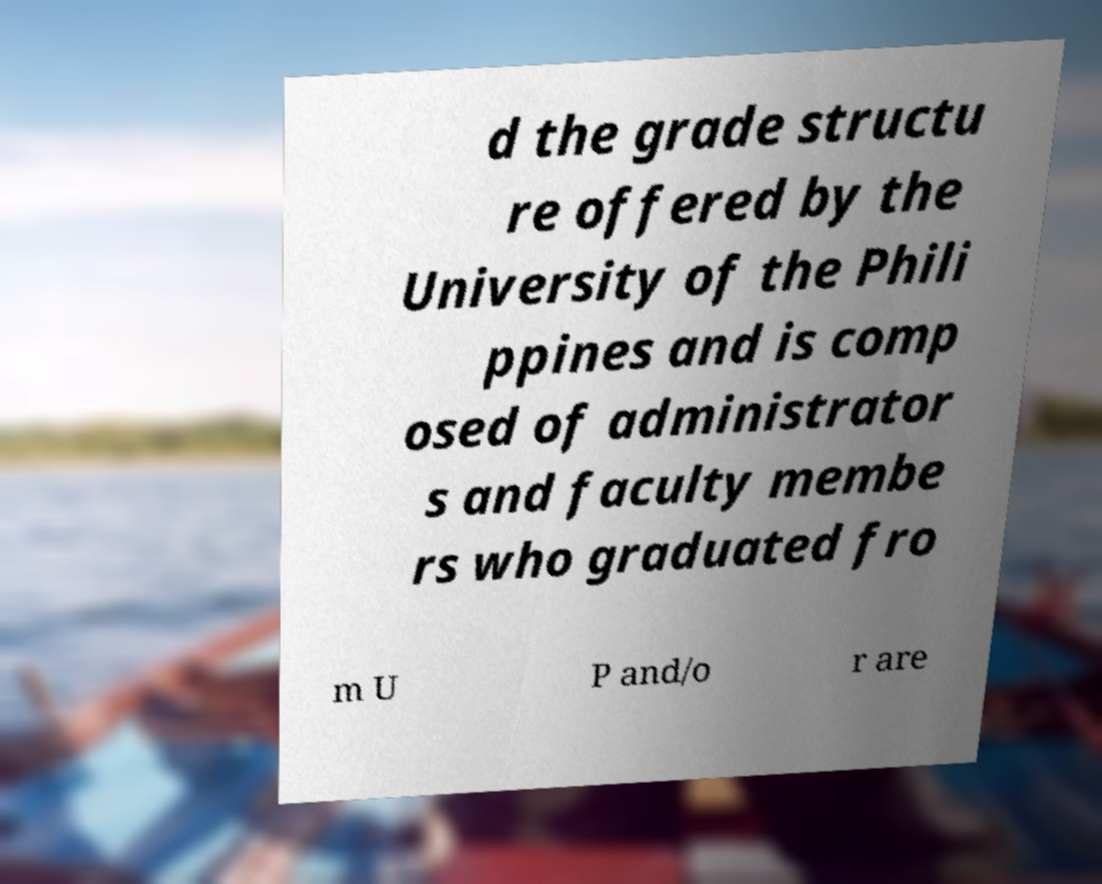Please read and relay the text visible in this image. What does it say? d the grade structu re offered by the University of the Phili ppines and is comp osed of administrator s and faculty membe rs who graduated fro m U P and/o r are 